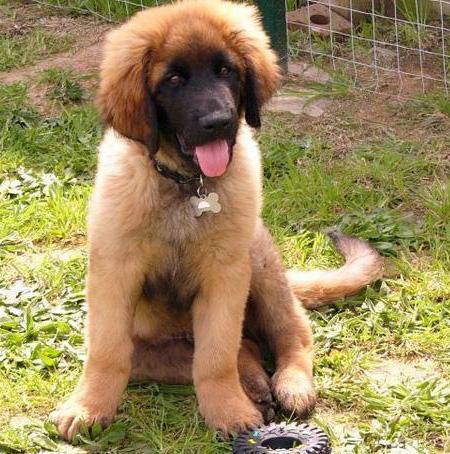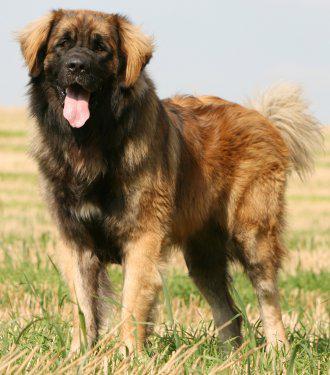The first image is the image on the left, the second image is the image on the right. Examine the images to the left and right. Is the description "Each dog's tongue is clearly visible." accurate? Answer yes or no. Yes. 